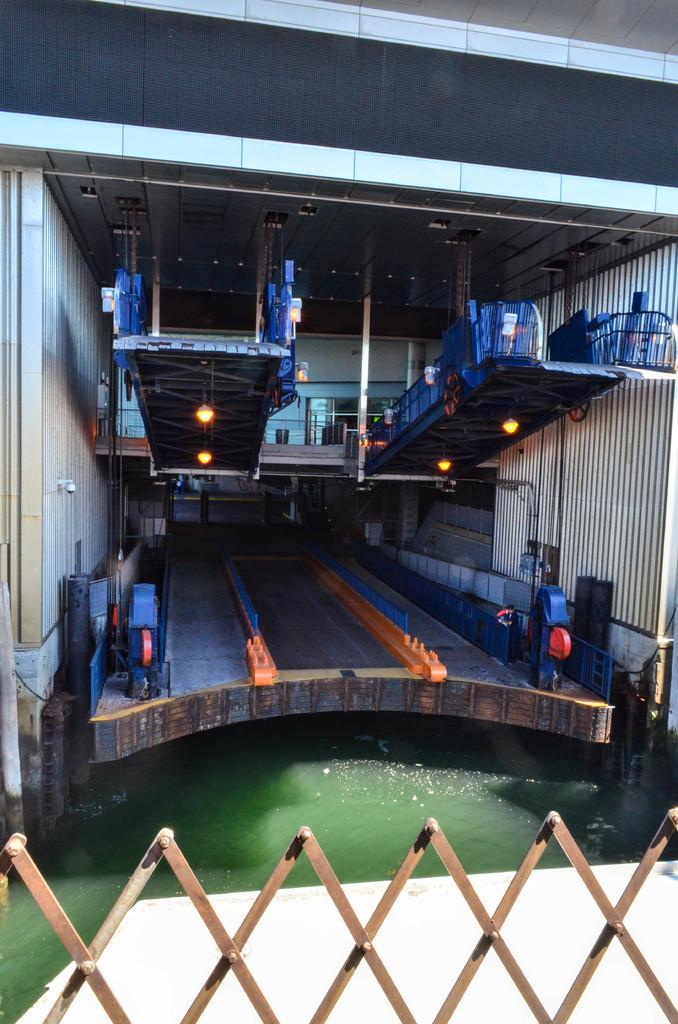What is located at the bottom of the image? There is a lake at the bottom of the image. What type of barrier can be seen in the image? There is a wooden fence in the image. What structure is in the middle of the image? There is a building in the middle of the image. What can be seen inside the building? Containers are visible inside the building. Can you see a twig being used as a tool in the image? There is no twig present in the image, nor is it being used as a tool. What trick is being performed by the containers in the image? There is no trick being performed by the containers in the image; they are simply visible inside the building. 